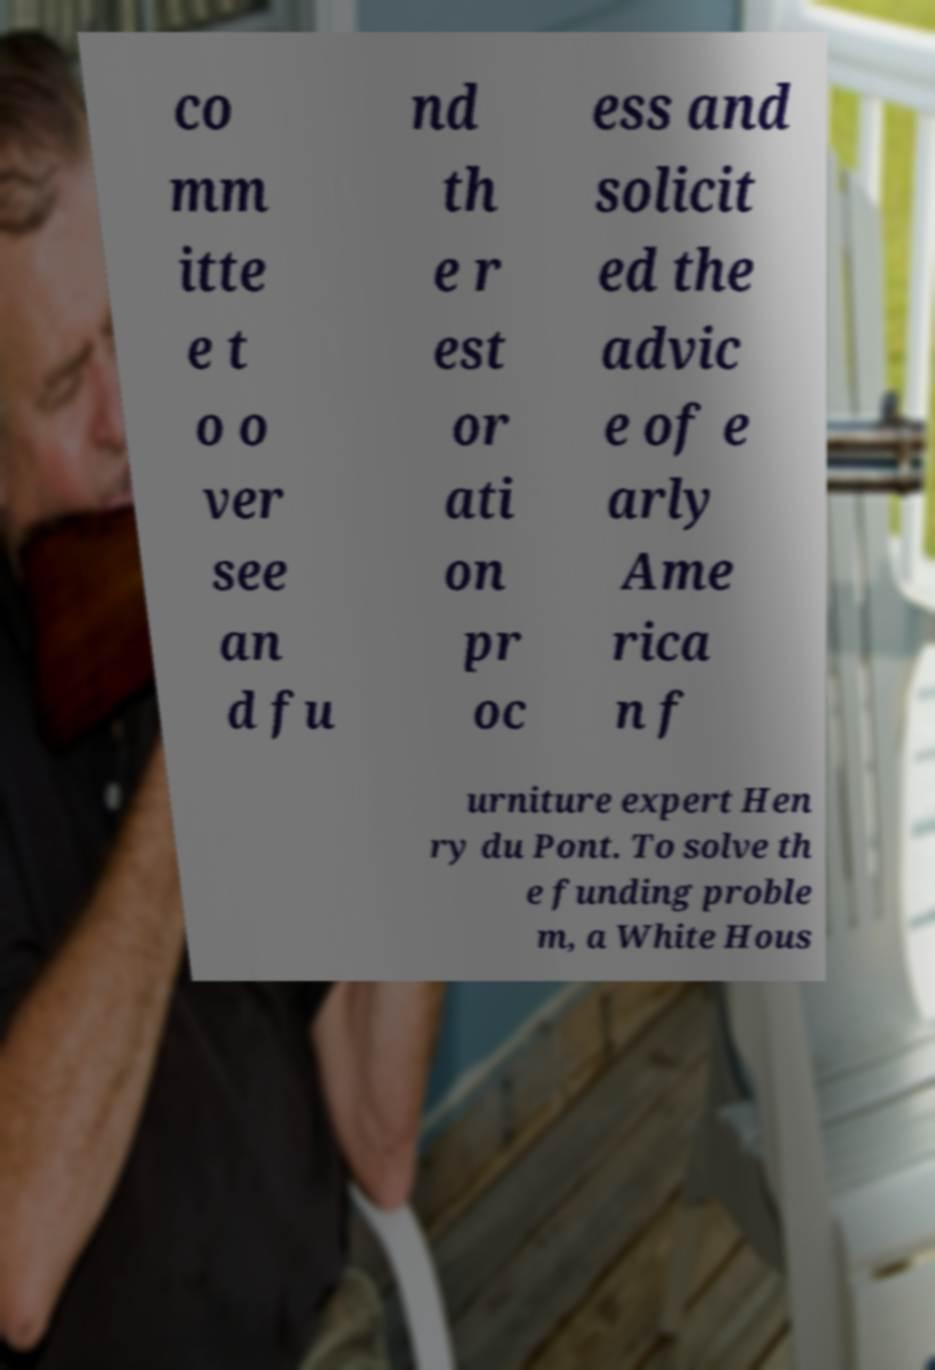I need the written content from this picture converted into text. Can you do that? co mm itte e t o o ver see an d fu nd th e r est or ati on pr oc ess and solicit ed the advic e of e arly Ame rica n f urniture expert Hen ry du Pont. To solve th e funding proble m, a White Hous 